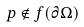Convert formula to latex. <formula><loc_0><loc_0><loc_500><loc_500>p \notin f ( \partial \Omega )</formula> 